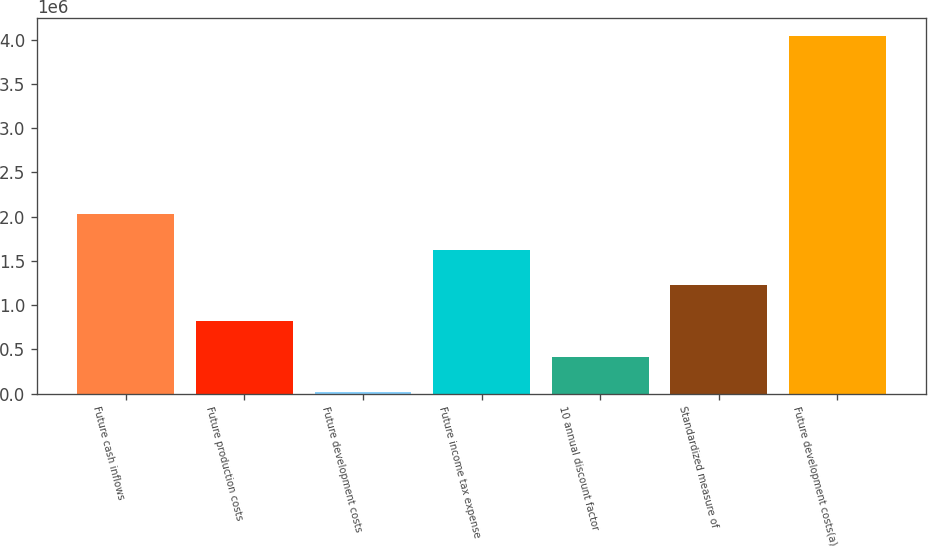Convert chart. <chart><loc_0><loc_0><loc_500><loc_500><bar_chart><fcel>Future cash inflows<fcel>Future production costs<fcel>Future development costs<fcel>Future income tax expense<fcel>10 annual discount factor<fcel>Standardized measure of<fcel>Future development costs(a)<nl><fcel>2.03024e+06<fcel>821857<fcel>16265<fcel>1.62745e+06<fcel>419061<fcel>1.22465e+06<fcel>4.04422e+06<nl></chart> 